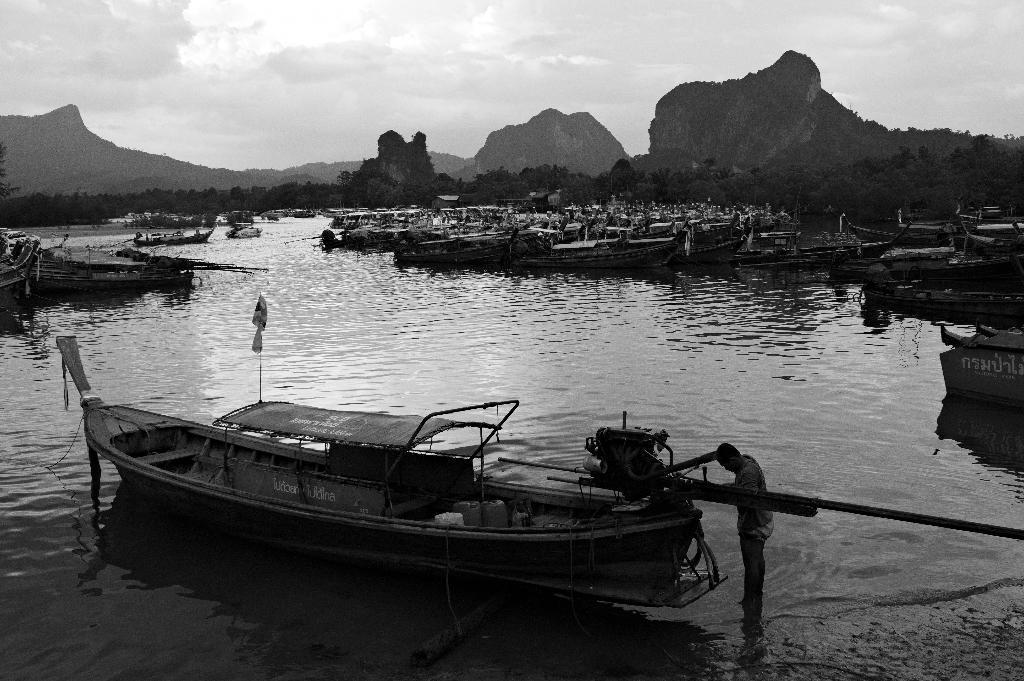In one or two sentences, can you explain what this image depicts? Here in this picture we can see water present over a place and in that we can see number of boats present and in the front we can see a person standing on the ground and we can also see number of people present in the far and we can also see mountains present, that are covered with grass and plants and we can also see plants and trees on the ground and we can see the sky is fully covered with clouds. 